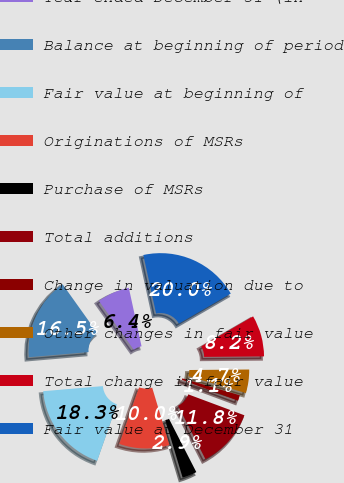Convert chart. <chart><loc_0><loc_0><loc_500><loc_500><pie_chart><fcel>Year ended December 31 (in<fcel>Balance at beginning of period<fcel>Fair value at beginning of<fcel>Originations of MSRs<fcel>Purchase of MSRs<fcel>Total additions<fcel>Change in valuation due to<fcel>Other changes in fair value<fcel>Total change in fair value<fcel>Fair value at December 31<nl><fcel>6.45%<fcel>16.5%<fcel>18.28%<fcel>10.0%<fcel>2.9%<fcel>11.78%<fcel>1.13%<fcel>4.68%<fcel>8.23%<fcel>20.05%<nl></chart> 